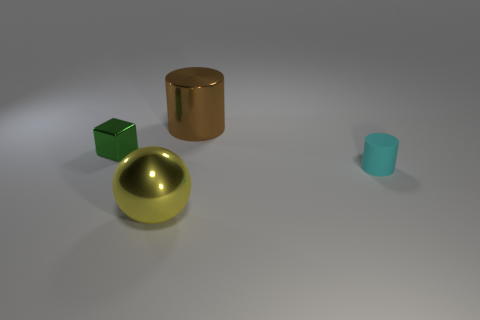Add 4 small matte cylinders. How many objects exist? 8 Subtract all balls. How many objects are left? 3 Add 2 tiny purple rubber cubes. How many tiny purple rubber cubes exist? 2 Subtract 0 yellow cubes. How many objects are left? 4 Subtract all big yellow metallic spheres. Subtract all brown cylinders. How many objects are left? 2 Add 4 small cylinders. How many small cylinders are left? 5 